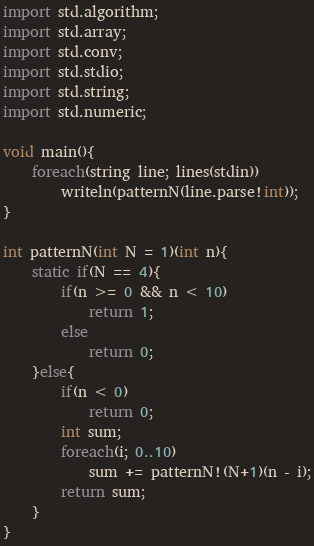Convert code to text. <code><loc_0><loc_0><loc_500><loc_500><_D_>import std.algorithm;
import std.array;
import std.conv;
import std.stdio;
import std.string;
import std.numeric;

void main(){
    foreach(string line; lines(stdin))
        writeln(patternN(line.parse!int));
}

int patternN(int N = 1)(int n){
    static if(N == 4){
        if(n >= 0 && n < 10)
            return 1;
        else
            return 0;
    }else{
        if(n < 0)
            return 0;
        int sum;
        foreach(i; 0..10)
            sum += patternN!(N+1)(n - i);
        return sum;
    }
}</code> 